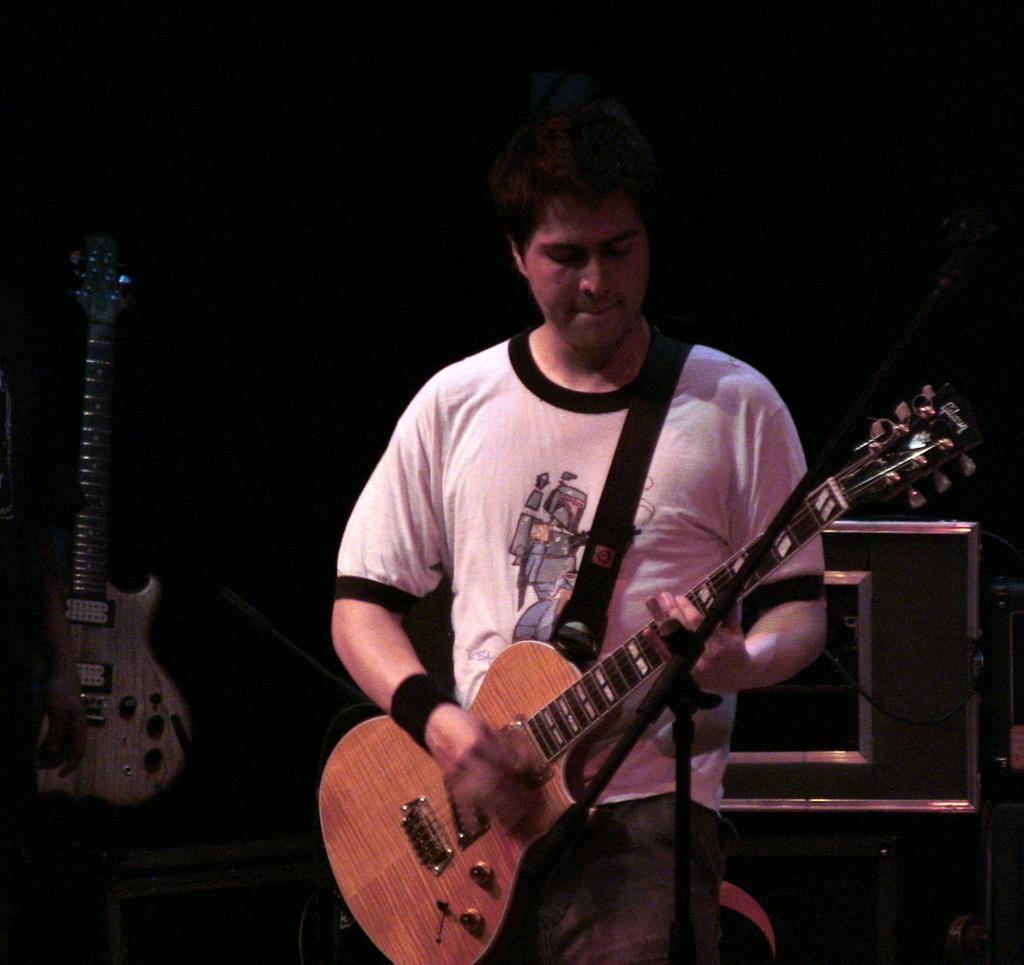Who or what is the main subject of the image? There is a person in the image. Where is the person located in the image? The person is standing at the center of the image. What is the person holding in his hands? The person is holding a guitar in his hands. Are there any other guitars visible in the image? Yes, there is another guitar present in the image, located at the left side. What type of pets can be seen playing with the guitar in the image? There are no pets present in the image, and therefore no such activity can be observed. 